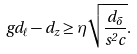<formula> <loc_0><loc_0><loc_500><loc_500>g d _ { \ell } - d _ { z } \geq \eta \sqrt { \frac { d _ { \delta } } { s ^ { 2 } c } } .</formula> 